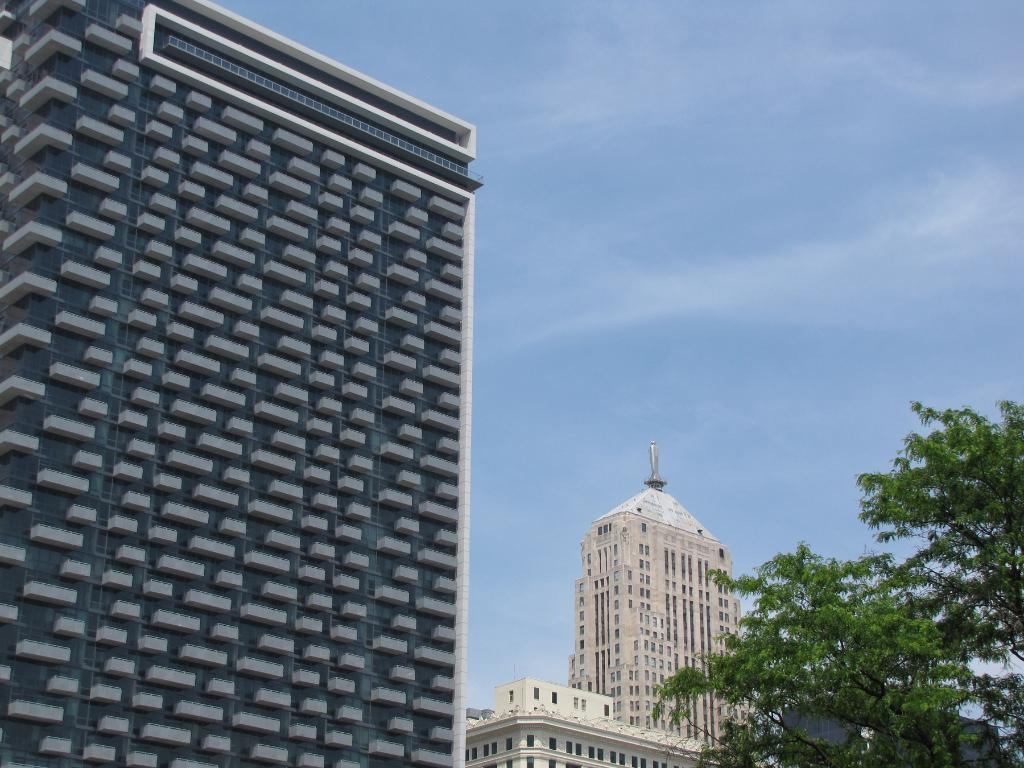What type of structures are present in the image? There are buildings in the image. What can be seen on the right side of the image? There is a tree on the right side of the image. What is visible at the top of the image? The sky is visible at the top of the image. What can be observed in the sky? There are clouds in the sky. What type of shirt is the tree wearing in the image? There is no shirt present in the image, as the tree is a plant and not a person. 